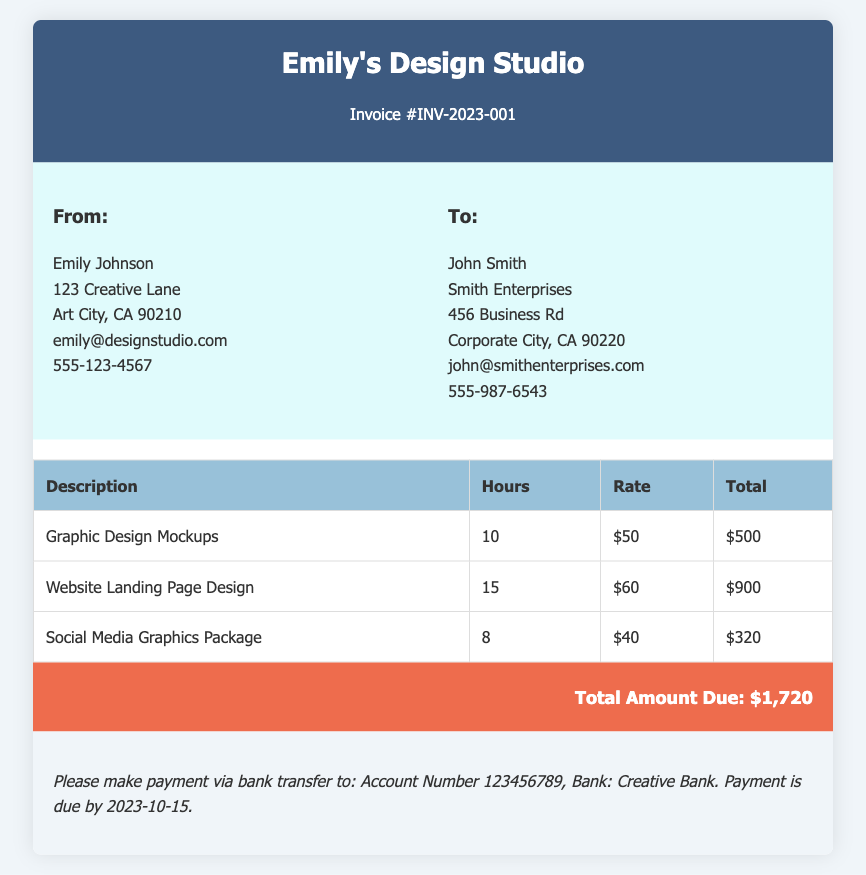What is the invoice number? The invoice number is prominently displayed in the header section of the document, which is INV-2023-001.
Answer: INV-2023-001 Who is the sender of the invoice? The sender's information is stated in the "From" section of the document, which indicates Emily Johnson as the sender.
Answer: Emily Johnson What is the total amount due? The total amount due is clearly presented at the bottom of the invoice, amounting to $1,720.
Answer: $1,720 How many hours were worked for the Graphic Design Mockups? The hours worked for each service are listed in the invoice table, showing that 10 hours were worked for the Graphic Design Mockups.
Answer: 10 What is the payment due date? The payment due date is mentioned in the payment instructions section, which is stated as 2023-10-15.
Answer: 2023-10-15 How much does an hour of Social Media Graphics Package cost? The rate per hour for each service is indicated in the invoice table, showing that the Social Media Graphics Package costs $40 per hour.
Answer: $40 What is the total for the Website Landing Page Design service? The total amount for each service can be found in the invoice table, and for the Website Landing Page Design, it amounts to $900.
Answer: $900 What bank should the payment be sent to? The bank information is included in the payment instructions, specifying Creative Bank as the receiving bank.
Answer: Creative Bank What city is Emily located in? The sender's address includes the city under the "From" section, which is Art City, CA.
Answer: Art City 